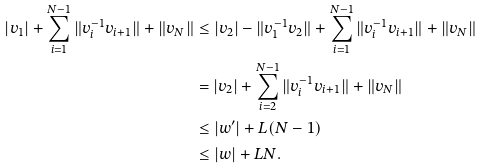Convert formula to latex. <formula><loc_0><loc_0><loc_500><loc_500>| v _ { 1 } | + \sum _ { i = 1 } ^ { N - 1 } \| v _ { i } ^ { - 1 } v _ { i + 1 } \| + \| v _ { N } \| & \leq | v _ { 2 } | - \| v _ { 1 } ^ { - 1 } v _ { 2 } \| + \sum _ { i = 1 } ^ { N - 1 } \| v _ { i } ^ { - 1 } v _ { i + 1 } \| + \| v _ { N } \| \\ & = | v _ { 2 } | + \sum _ { i = 2 } ^ { N - 1 } \| v _ { i } ^ { - 1 } v _ { i + 1 } \| + \| v _ { N } \| \\ & \leq | w ^ { \prime } | + L ( N - 1 ) \\ & \leq | w | + L N .</formula> 